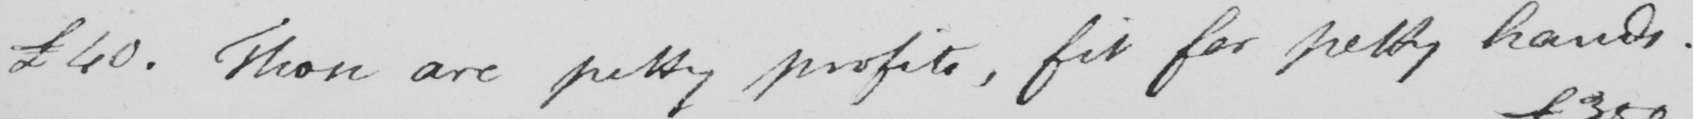Transcribe the text shown in this historical manuscript line. £40 . Those are pretty profits , fit for petty hands . 